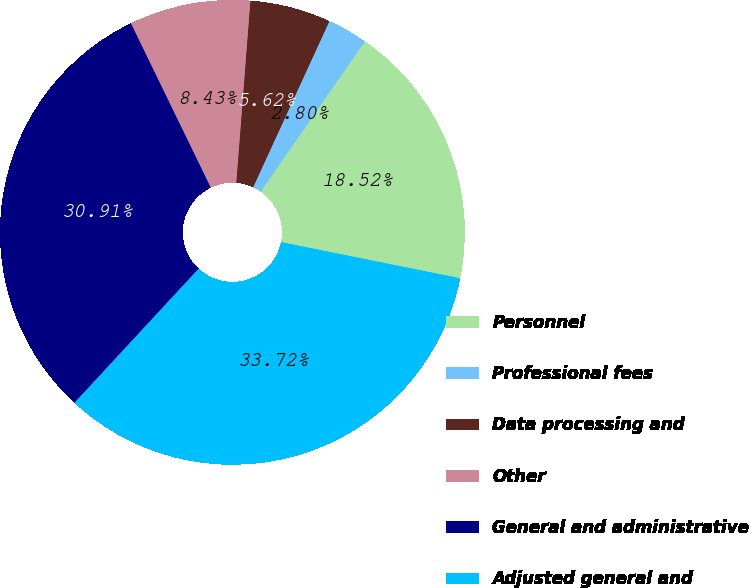Convert chart to OTSL. <chart><loc_0><loc_0><loc_500><loc_500><pie_chart><fcel>Personnel<fcel>Professional fees<fcel>Data processing and<fcel>Other<fcel>General and administrative<fcel>Adjusted general and<nl><fcel>18.52%<fcel>2.8%<fcel>5.62%<fcel>8.43%<fcel>30.91%<fcel>33.72%<nl></chart> 